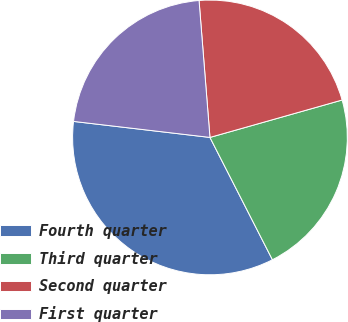Convert chart. <chart><loc_0><loc_0><loc_500><loc_500><pie_chart><fcel>Fourth quarter<fcel>Third quarter<fcel>Second quarter<fcel>First quarter<nl><fcel>34.38%<fcel>21.88%<fcel>21.88%<fcel>21.88%<nl></chart> 